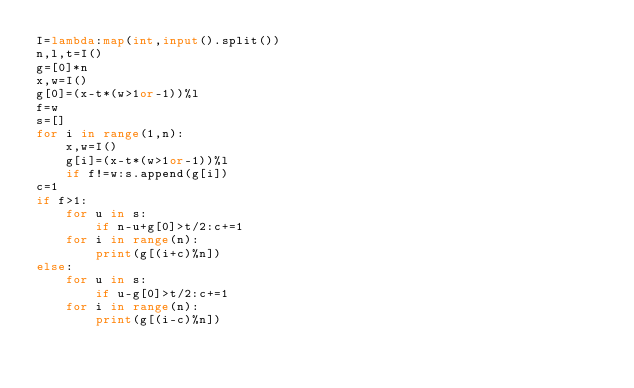Convert code to text. <code><loc_0><loc_0><loc_500><loc_500><_Python_>I=lambda:map(int,input().split())
n,l,t=I()
g=[0]*n
x,w=I()
g[0]=(x-t*(w>1or-1))%l
f=w
s=[]
for i in range(1,n):
    x,w=I()
    g[i]=(x-t*(w>1or-1))%l
    if f!=w:s.append(g[i])
c=1
if f>1:
    for u in s:
        if n-u+g[0]>t/2:c+=1
    for i in range(n):
        print(g[(i+c)%n])
else:
    for u in s:
        if u-g[0]>t/2:c+=1
    for i in range(n):
        print(g[(i-c)%n])</code> 